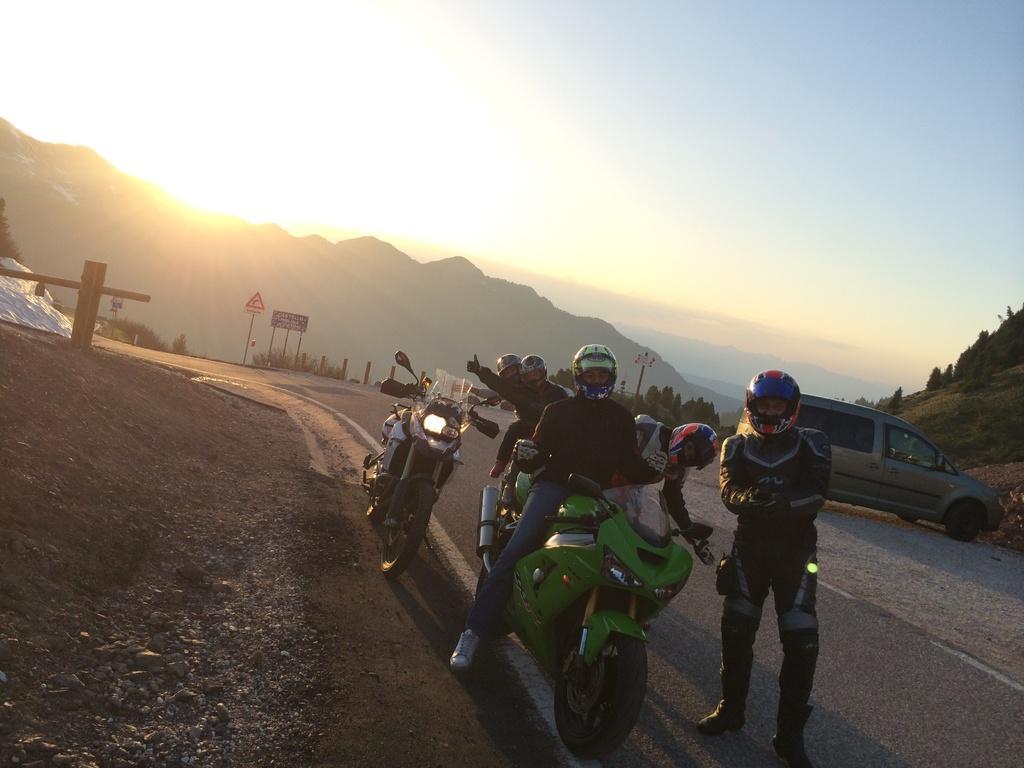Can you describe this image briefly? In this image in the center there are persons standing and there are bikes. In the background there are boards with some text written on it, there are trees and mountains and there is a car and at the top there is sky and there is sun which is visible. 